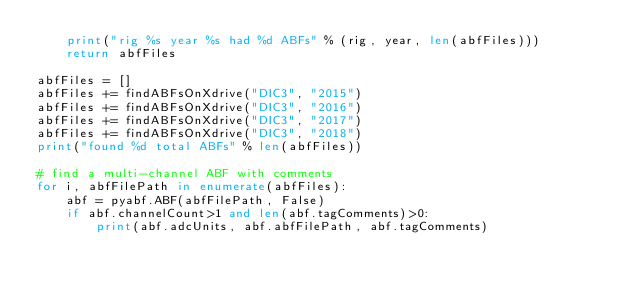Convert code to text. <code><loc_0><loc_0><loc_500><loc_500><_Python_>    print("rig %s year %s had %d ABFs" % (rig, year, len(abfFiles)))
    return abfFiles

abfFiles = []
abfFiles += findABFsOnXdrive("DIC3", "2015")
abfFiles += findABFsOnXdrive("DIC3", "2016")
abfFiles += findABFsOnXdrive("DIC3", "2017")
abfFiles += findABFsOnXdrive("DIC3", "2018")
print("found %d total ABFs" % len(abfFiles))

# find a multi-channel ABF with comments
for i, abfFilePath in enumerate(abfFiles):
    abf = pyabf.ABF(abfFilePath, False)    
    if abf.channelCount>1 and len(abf.tagComments)>0:
        print(abf.adcUnits, abf.abfFilePath, abf.tagComments)
</code> 